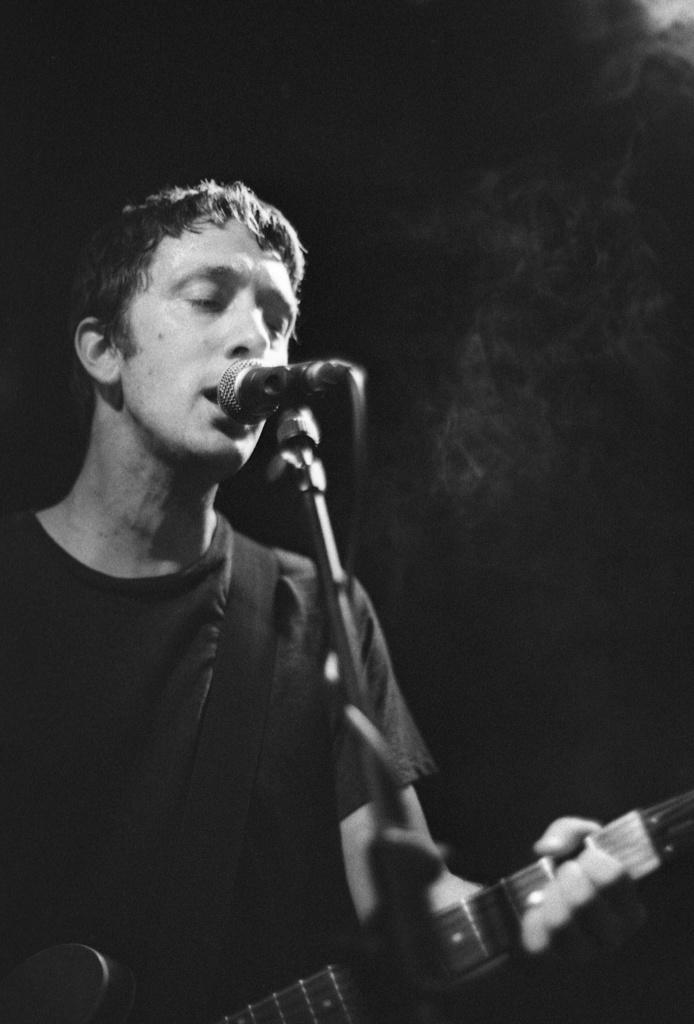What is the person doing in the image? The person is standing and playing the guitar while singing a song. What object is the person holding in the image? The person is holding a guitar in the image. What activity is the person engaged in while holding the guitar? The person is singing a song while playing the guitar. What type of snake can be seen slithering around the person's feet in the image? There is no snake present in the image; the person is standing and playing the guitar while singing a song. 